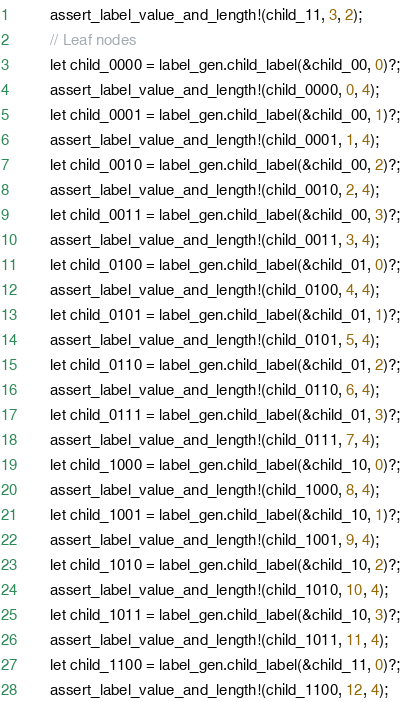<code> <loc_0><loc_0><loc_500><loc_500><_Rust_>        assert_label_value_and_length!(child_11, 3, 2);
        // Leaf nodes
        let child_0000 = label_gen.child_label(&child_00, 0)?;
        assert_label_value_and_length!(child_0000, 0, 4);
        let child_0001 = label_gen.child_label(&child_00, 1)?;
        assert_label_value_and_length!(child_0001, 1, 4);
        let child_0010 = label_gen.child_label(&child_00, 2)?;
        assert_label_value_and_length!(child_0010, 2, 4);
        let child_0011 = label_gen.child_label(&child_00, 3)?;
        assert_label_value_and_length!(child_0011, 3, 4);
        let child_0100 = label_gen.child_label(&child_01, 0)?;
        assert_label_value_and_length!(child_0100, 4, 4);
        let child_0101 = label_gen.child_label(&child_01, 1)?;
        assert_label_value_and_length!(child_0101, 5, 4);
        let child_0110 = label_gen.child_label(&child_01, 2)?;
        assert_label_value_and_length!(child_0110, 6, 4);
        let child_0111 = label_gen.child_label(&child_01, 3)?;
        assert_label_value_and_length!(child_0111, 7, 4);
        let child_1000 = label_gen.child_label(&child_10, 0)?;
        assert_label_value_and_length!(child_1000, 8, 4);
        let child_1001 = label_gen.child_label(&child_10, 1)?;
        assert_label_value_and_length!(child_1001, 9, 4);
        let child_1010 = label_gen.child_label(&child_10, 2)?;
        assert_label_value_and_length!(child_1010, 10, 4);
        let child_1011 = label_gen.child_label(&child_10, 3)?;
        assert_label_value_and_length!(child_1011, 11, 4);
        let child_1100 = label_gen.child_label(&child_11, 0)?;
        assert_label_value_and_length!(child_1100, 12, 4);</code> 